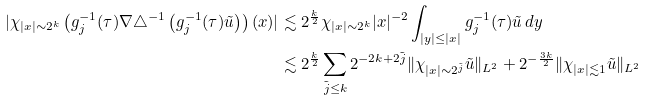Convert formula to latex. <formula><loc_0><loc_0><loc_500><loc_500>| \chi _ { | x | \sim 2 ^ { k } } \left ( g _ { j } ^ { - 1 } ( \tau ) \nabla \triangle ^ { - 1 } \left ( g _ { j } ^ { - 1 } ( \tau ) \tilde { u } \right ) \right ) ( x ) | & \lesssim 2 ^ { \frac { k } { 2 } } \chi _ { | x | \sim 2 ^ { k } } | x | ^ { - 2 } \int _ { | y | \leq | x | } g _ { j } ^ { - 1 } ( \tau ) \tilde { u } \, d y \\ & \lesssim 2 ^ { \frac { k } { 2 } } \sum _ { \tilde { j } \leq k } 2 ^ { - 2 k + 2 \tilde { j } } \| \chi _ { | x | \sim 2 ^ { \tilde { j } } } \tilde { u } \| _ { L ^ { 2 } } + 2 ^ { - \frac { 3 k } { 2 } } \| \chi _ { | x | \lesssim 1 } \tilde { u } \| _ { L ^ { 2 } }</formula> 